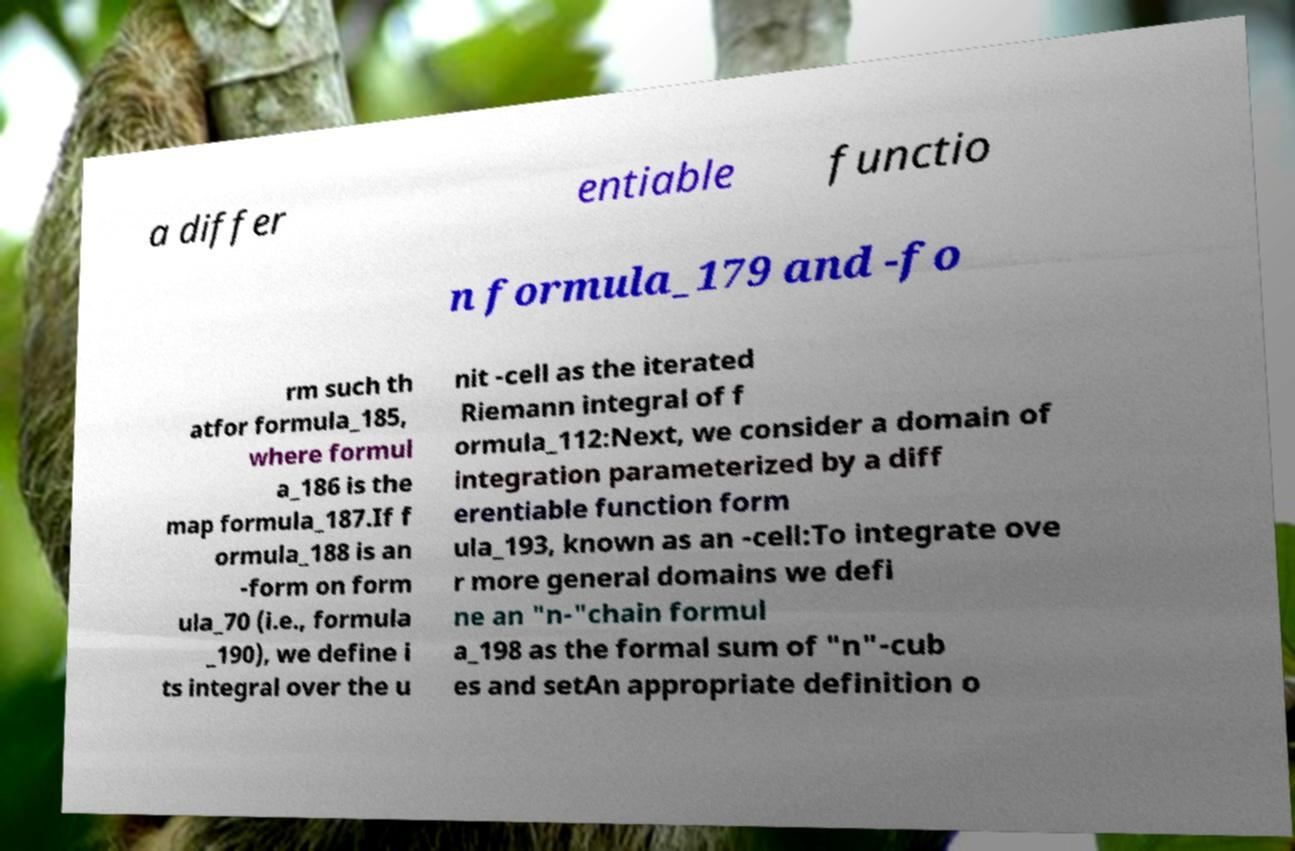What messages or text are displayed in this image? I need them in a readable, typed format. a differ entiable functio n formula_179 and -fo rm such th atfor formula_185, where formul a_186 is the map formula_187.If f ormula_188 is an -form on form ula_70 (i.e., formula _190), we define i ts integral over the u nit -cell as the iterated Riemann integral of f ormula_112:Next, we consider a domain of integration parameterized by a diff erentiable function form ula_193, known as an -cell:To integrate ove r more general domains we defi ne an "n-"chain formul a_198 as the formal sum of "n"-cub es and setAn appropriate definition o 